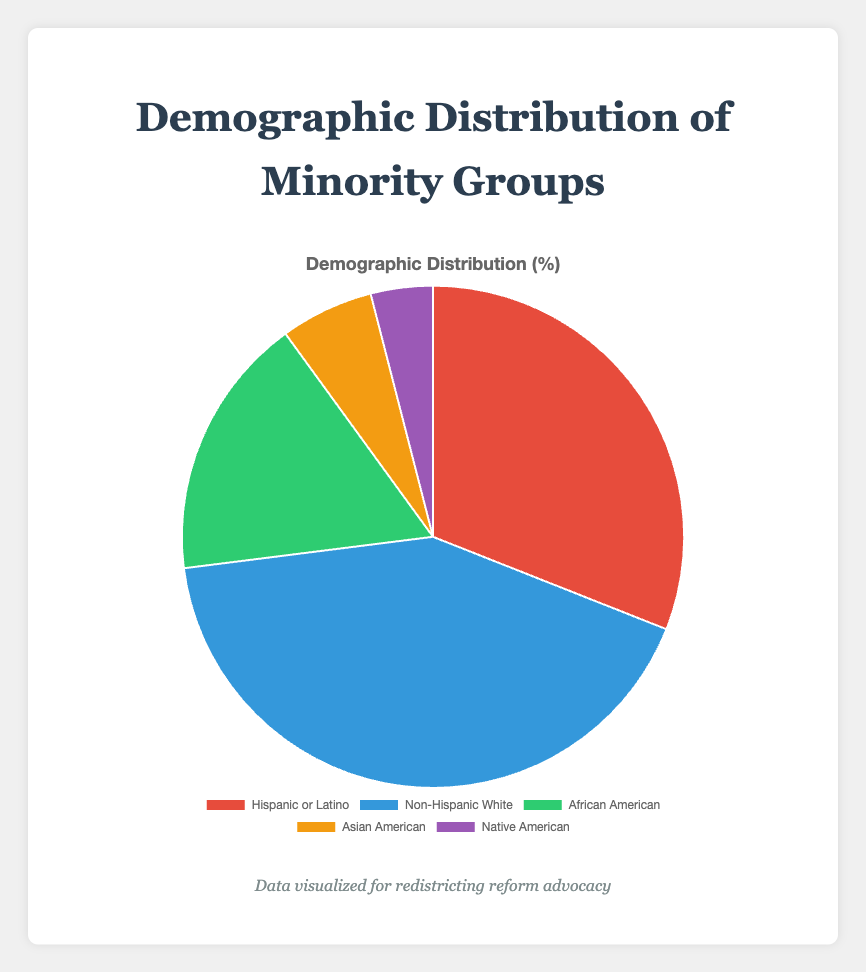What's the percentage of the Hispanic or Latino group? The chart shows that the Hispanic or Latino group accounts for 31% of the demographic distribution.
Answer: 31% Which group has the largest percentage? By observing the pie chart, the Non-Hispanic White group has the largest segment, which is 42%.
Answer: Non-Hispanic White Which group is represented by the green segment? The chart uses color to represent each demographic. The green segment corresponds to the African American group.
Answer: African American What is the total percentage of the Hispanic or Latino and African American groups? The Hispanic or Latino group is 31%, and the African American group is 17%. Summing them up: 31% + 17% = 48%.
Answer: 48% How does the percentage of the Native American group compare to the Asian American group? The Native American group accounts for 4%, while the Asian American group accounts for 6%. Therefore, the Native American percentage is lower.
Answer: Lower What's the difference in percentage between the group with the highest value and the group with the lowest value? The Non-Hispanic White group has the highest percentage at 42%, and the Native American group has the lowest at 4%. The difference is 42% - 4% = 38%.
Answer: 38% What is the average percentage of all the groups? The sum of the percentages of all the groups is 31% + 42% + 17% + 6% + 4% = 100%. There are 5 groups. The average is 100% / 5 = 20%.
Answer: 20% If we combined the Asian American and Native American groups, what would their total percentage be? The Asian American group has a percentage of 6%, and the Native American group has a percentage of 4%. Summing them up: 6% + 4% = 10%.
Answer: 10% Which group makes up nearly one-third of the population? The Hispanic or Latino group accounts for 31% of the population, which is approximately one-third.
Answer: Hispanic or Latino 